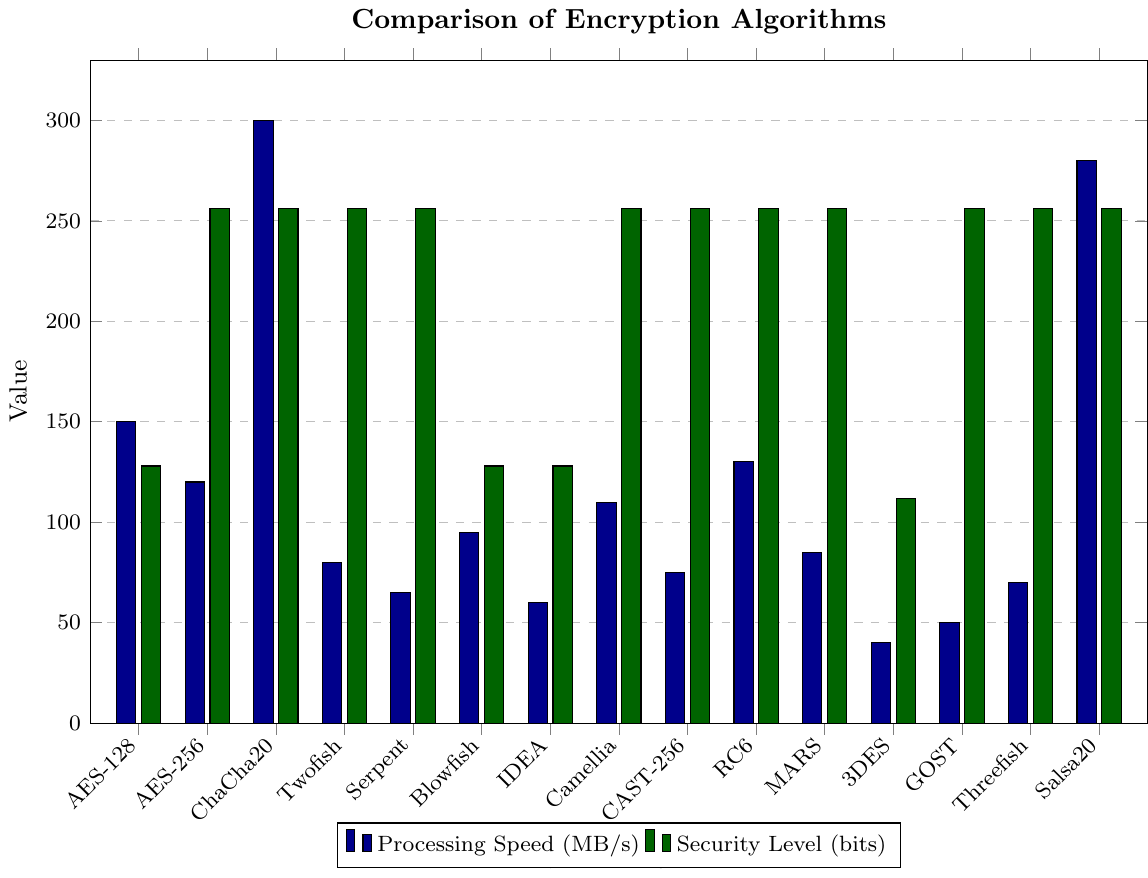Which encryption algorithm has the highest processing speed? Look at the heights of the bars corresponding to processing speed (filled in dark blue). The tallest bar represents the highest processing speed.
Answer: ChaCha20 Which encryption algorithm offers the highest security level? Check the heights of the bars representing security levels (filled in dark green). All algorithms except 3DES have the highest bar at 256 bits.
Answer: AES-256, ChaCha20, Twofish, Serpent, Camellia, CAST-256, RC6, MARS, GOST, Threefish, Salsa20 What is the difference in processing speed between the fastest and the slowest algorithms? Identify the tallest and shortest dark blue bars. The values for ChaCha20 and 3DES are 300 MB/s and 40 MB/s, respectively. The difference is 300 - 40.
Answer: 260 MB/s How many algorithms have a processing speed above 100 MB/s? Count the number of blue bars with heights above 100 MB/s.
Answer: 6 (AES-128, AES-256, ChaCha20, RC6, Salsa20, Camellia) What is the combined security level of Blowfish and IDEA? Check the heights of green bars for Blowfish and IDEA, which are both 128 bits. The combined security level is 128 + 128.
Answer: 256 bits Which algorithm has a higher processing speed: Twofish or Serpent? Compare the heights of the dark blue bars for Twofish (80 MB/s) and Serpent (65 MB/s).
Answer: Twofish Which algorithm has the lowest processing speed among those with a 256-bit security level? Identify the algorithm with the shortest dark blue bar among those whose green bar reaches 256 bits. The algorithm is Serpent with 65 MB/s.
Answer: Serpent What is the average processing speed of AES-128, AES-256, and ChaCha20? Find the processing speeds of these three algorithms (150 MB/s, 120 MB/s, 300 MB/s), sum them up (150 + 120 + 300 = 570), and divide by 3.
Answer: 190 MB/s Do any algorithms have the same processing speed? Check for any algorithms where the heights of the dark blue bars match.
Answer: No Which algorithm that has a security level of 256 bits has the closest processing speed to GOST? Find the processing speed of GOST (50 MB/s) and compare it to other 256-bit algorithms. Threefish has a processing speed of 70 MB/s, which is the closest to 50 MB/s.
Answer: Threefish 